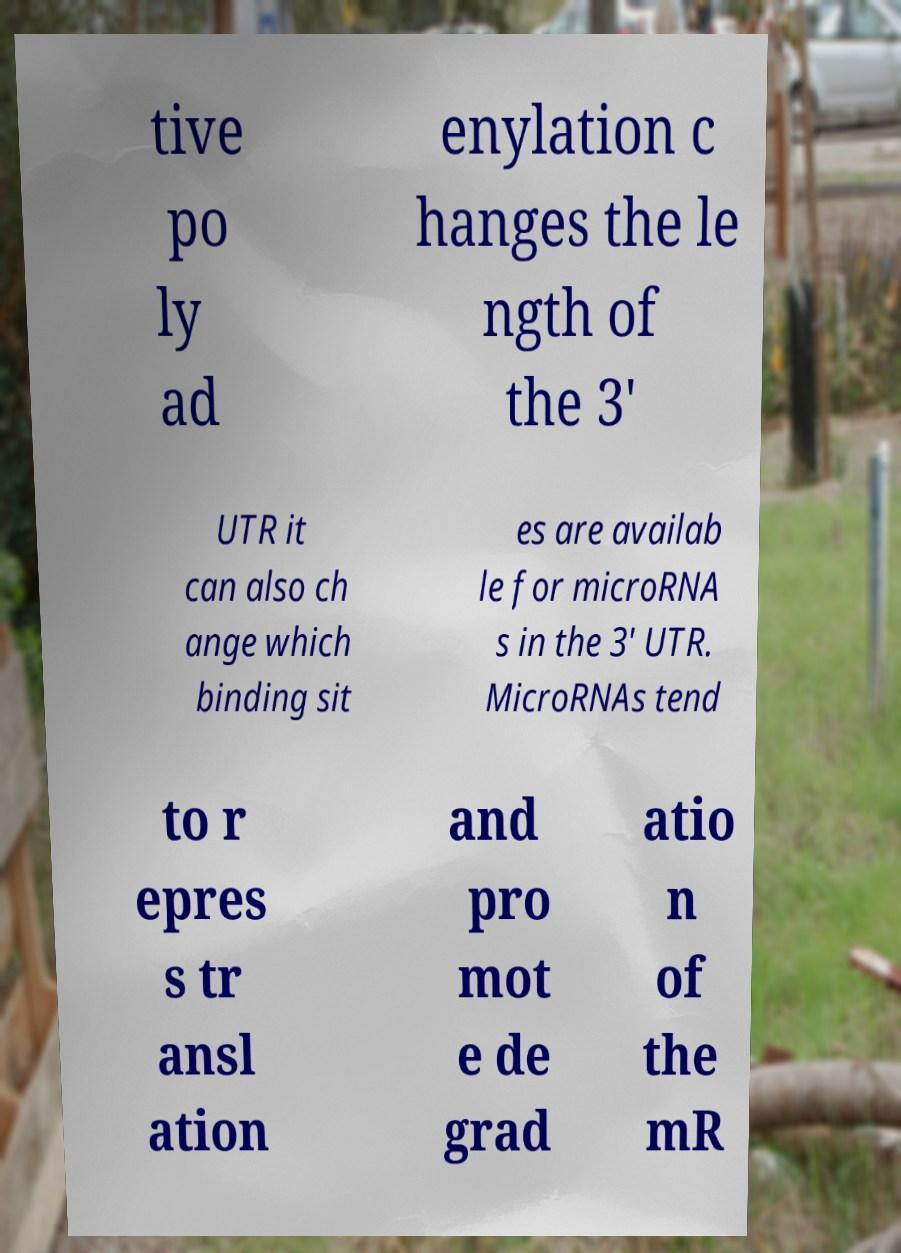For documentation purposes, I need the text within this image transcribed. Could you provide that? tive po ly ad enylation c hanges the le ngth of the 3' UTR it can also ch ange which binding sit es are availab le for microRNA s in the 3′ UTR. MicroRNAs tend to r epres s tr ansl ation and pro mot e de grad atio n of the mR 